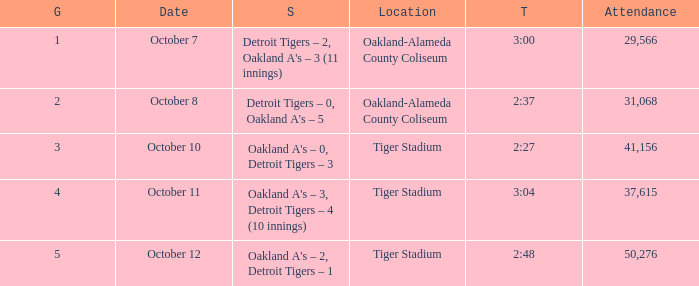What is the number of people in attendance when the time is 3:00? 29566.0. 